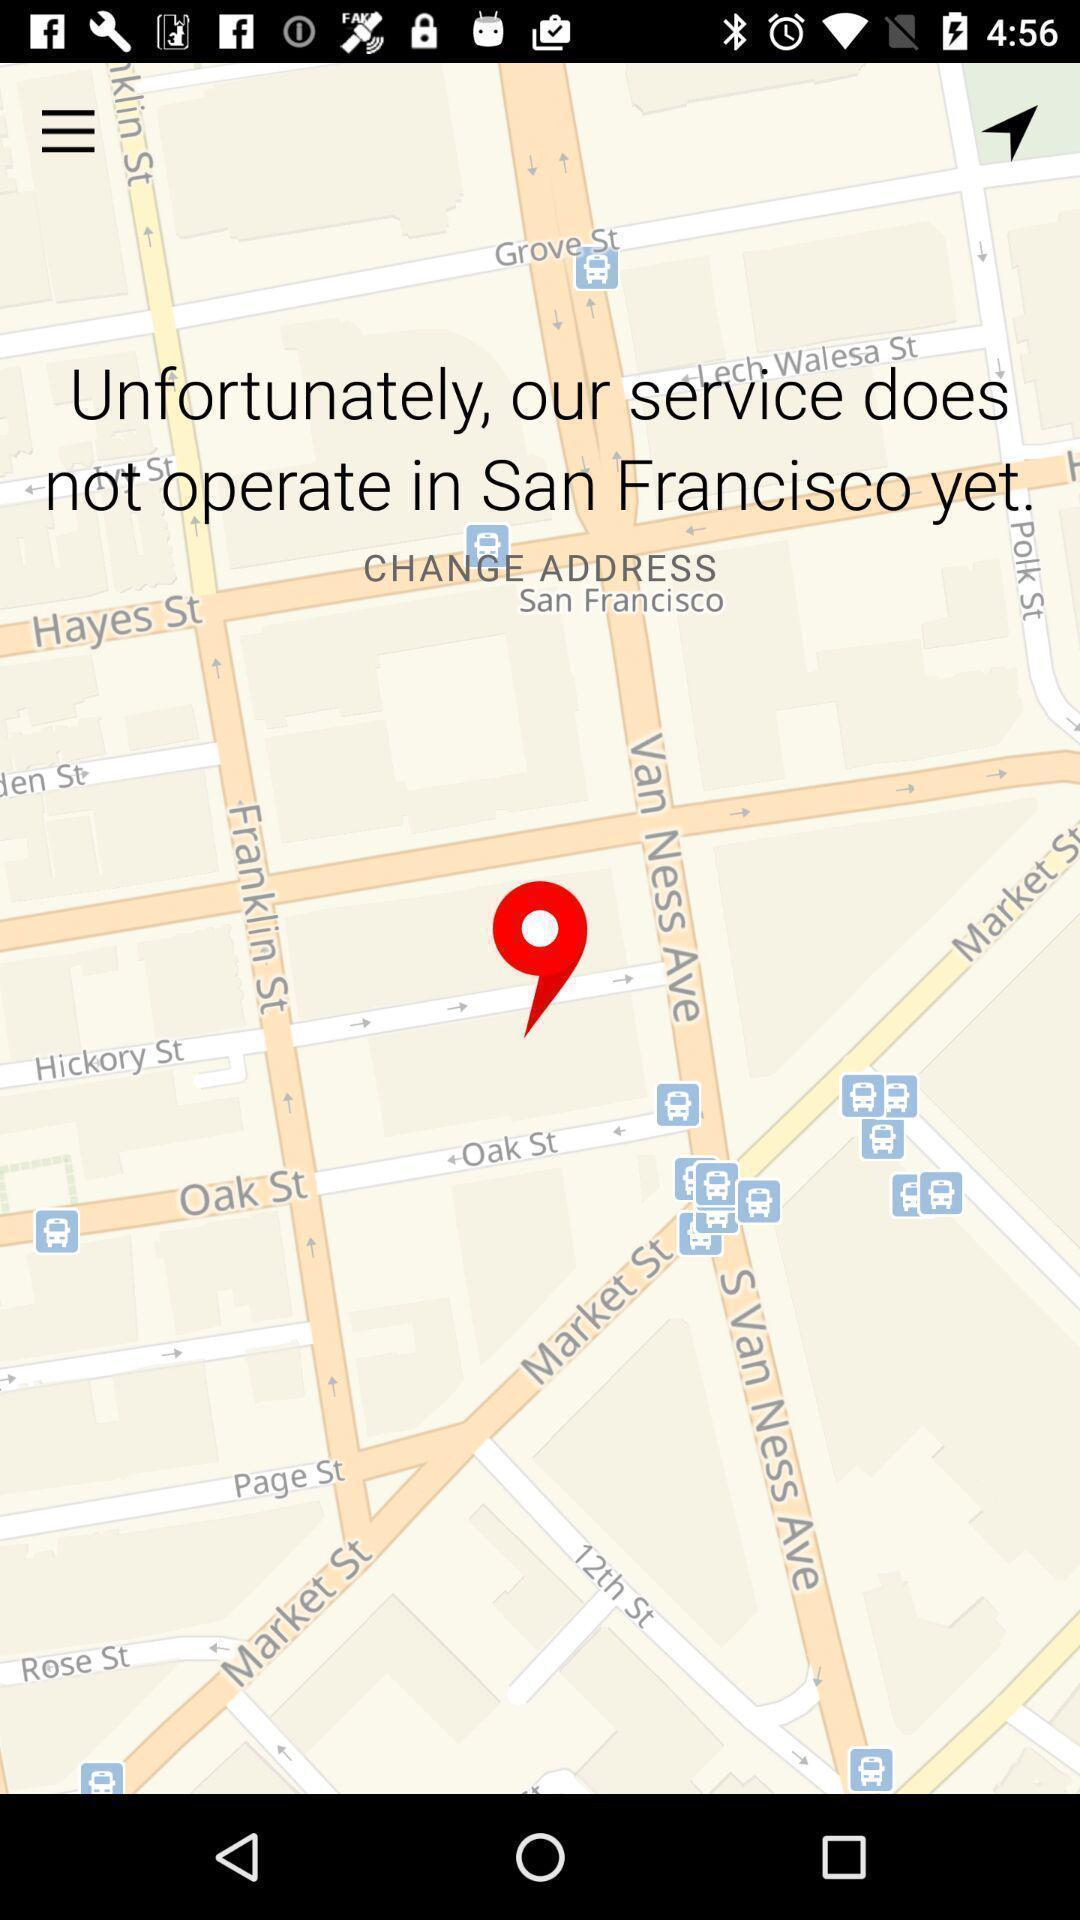Tell me what you see in this picture. Screen shows about a mobile taxi app. 